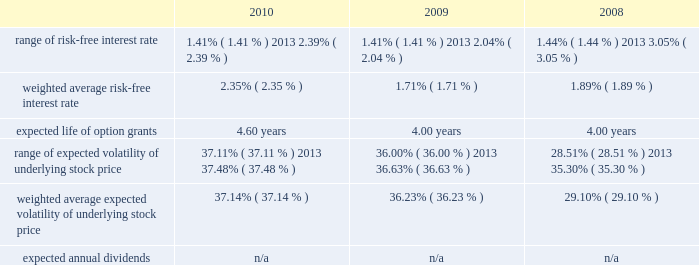American tower corporation and subsidiaries notes to consolidated financial statements assessments in each of the tax jurisdictions resulting from these examinations .
The company believes that adequate provisions have been made for income taxes for all periods through december 31 , 2010 .
12 .
Stock-based compensation the company recognized stock-based compensation of $ 52.6 million , $ 60.7 million and $ 54.8 million for the years ended december 31 , 2010 , 2009 and 2008 , respectively .
Stock-based compensation for the year ended december 31 , 2009 included $ 6.9 million related to the modification of the vesting and exercise terms for certain employee 2019s equity awards .
The company did not capitalize any stock-based compensation during the years ended december 31 , 2010 and 2009 .
Summary of stock-based compensation plans 2014the company maintains equity incentive plans that provide for the grant of stock-based awards to its directors , officers and employees .
Under the 2007 equity incentive plan ( 201c2007 plan 201d ) , which provides for the grant of non-qualified and incentive stock options , as well as restricted stock units , restricted stock and other stock-based awards , exercise prices in the case of non-qualified and incentive stock options are not less than the fair market value of the underlying common stock on the date of grant .
Equity awards typically vest ratably over various periods , generally four years , and generally expire ten years from the date of grant .
Stock options 2014as of december 31 , 2010 , the company had the ability to grant stock-based awards with respect to an aggregate of 22.0 million shares of common stock under the 2007 plan .
The fair value of each option grant is estimated on the date of grant using the black-scholes option pricing model based on the assumptions noted in the table below .
The risk-free treasury rate is based on the u.s .
Treasury yield in effect at the accounting measurement date .
The expected life ( estimated period of time outstanding ) was estimated using the vesting term and historical exercise behavior of company employees .
The expected volatility was based on historical volatility for a period equal to the expected life of the stock options .
Key assumptions used to apply this pricing model are as follows: .
The weighted average grant date fair value per share during the years ended december 31 , 2010 , 2009 and 2008 was $ 15.03 , $ 8.90 and $ 9.55 , respectively .
The intrinsic value of stock options exercised during the years ended december 31 , 2010 , 2009 and 2008 was $ 62.7 million , $ 40.1 million and $ 99.1 million , respectively .
As of december 31 , 2010 , total unrecognized compensation expense related to unvested stock options was approximately $ 27.7 million and is expected to be recognized over a weighted average period of approximately two years .
The amount of cash received from the exercise of stock options was approximately $ 129.1 million during the year ended december 31 , 2010 .
During the year ended december 31 , 2010 , the company realized approximately $ 0.3 million of state tax benefits from the exercise of stock options. .
What is the percentage change in the intrinsic value of stock options from 2008 to 2009? 
Computations: ((62.7 - 40.1) / 40.1)
Answer: 0.56359. 